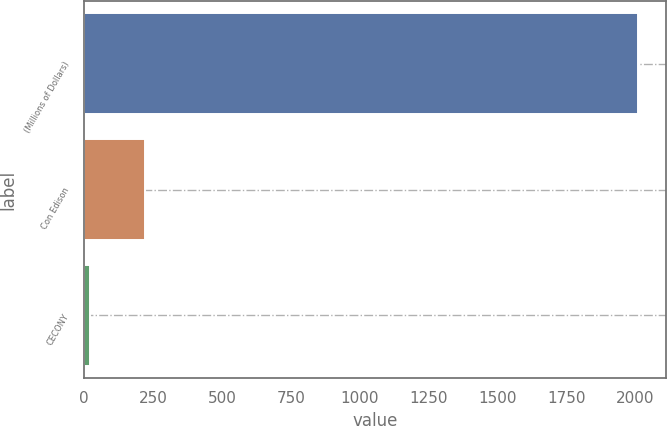Convert chart to OTSL. <chart><loc_0><loc_0><loc_500><loc_500><bar_chart><fcel>(Millions of Dollars)<fcel>Con Edison<fcel>CECONY<nl><fcel>2010<fcel>219.9<fcel>21<nl></chart> 